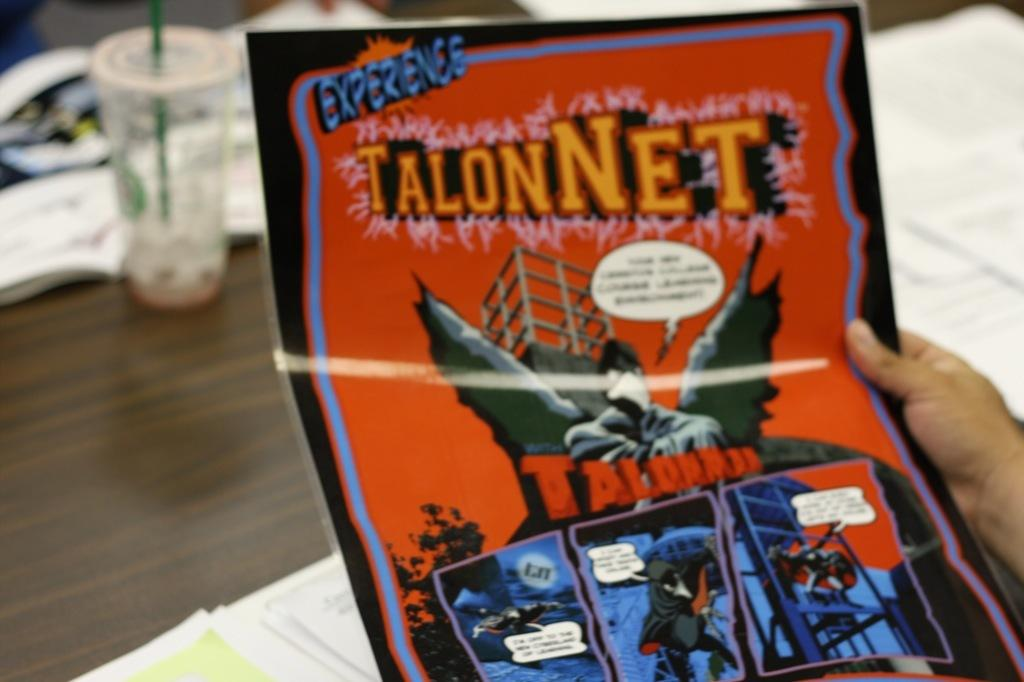Provide a one-sentence caption for the provided image. The TalonNet comic book is not from the Marvel Comics brand. 